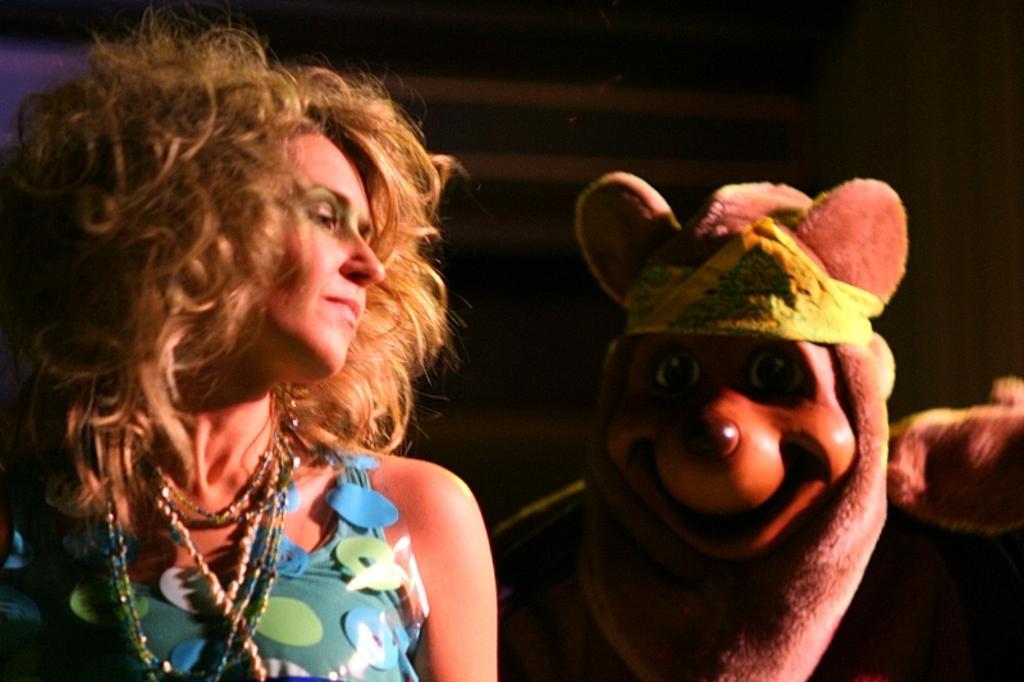Could you give a brief overview of what you see in this image? In the foreground of this picture, there is woman in blue dress. Behind her, there is a person wearing a mask on his head. On top, there is a wall and a curtain. 